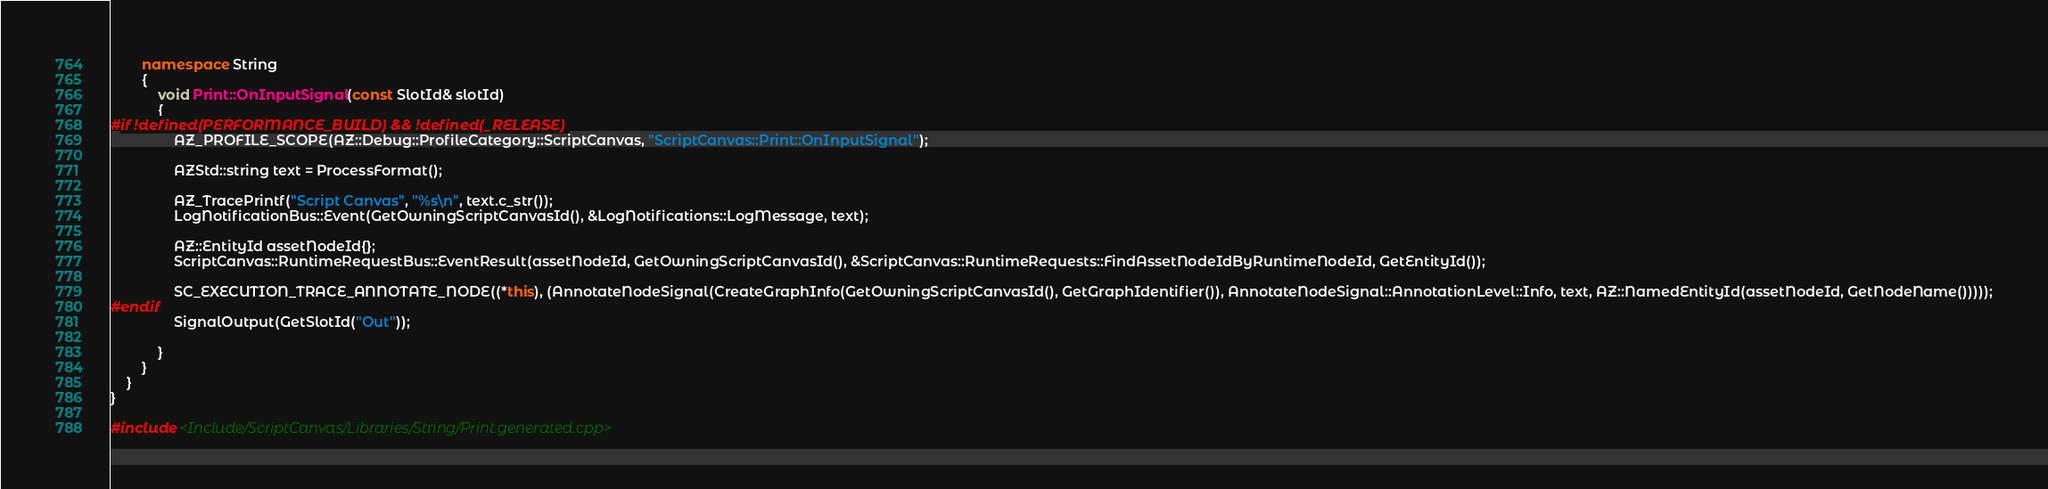<code> <loc_0><loc_0><loc_500><loc_500><_C++_>        namespace String
        {
            void Print::OnInputSignal(const SlotId& slotId)
            {
#if !defined(PERFORMANCE_BUILD) && !defined(_RELEASE) 
                AZ_PROFILE_SCOPE(AZ::Debug::ProfileCategory::ScriptCanvas, "ScriptCanvas::Print::OnInputSignal");

                AZStd::string text = ProcessFormat();

                AZ_TracePrintf("Script Canvas", "%s\n", text.c_str());
                LogNotificationBus::Event(GetOwningScriptCanvasId(), &LogNotifications::LogMessage, text);

                AZ::EntityId assetNodeId{};
                ScriptCanvas::RuntimeRequestBus::EventResult(assetNodeId, GetOwningScriptCanvasId(), &ScriptCanvas::RuntimeRequests::FindAssetNodeIdByRuntimeNodeId, GetEntityId());

                SC_EXECUTION_TRACE_ANNOTATE_NODE((*this), (AnnotateNodeSignal(CreateGraphInfo(GetOwningScriptCanvasId(), GetGraphIdentifier()), AnnotateNodeSignal::AnnotationLevel::Info, text, AZ::NamedEntityId(assetNodeId, GetNodeName()))));
#endif
                SignalOutput(GetSlotId("Out"));

            }
        }
    }
}

#include <Include/ScriptCanvas/Libraries/String/Print.generated.cpp></code> 